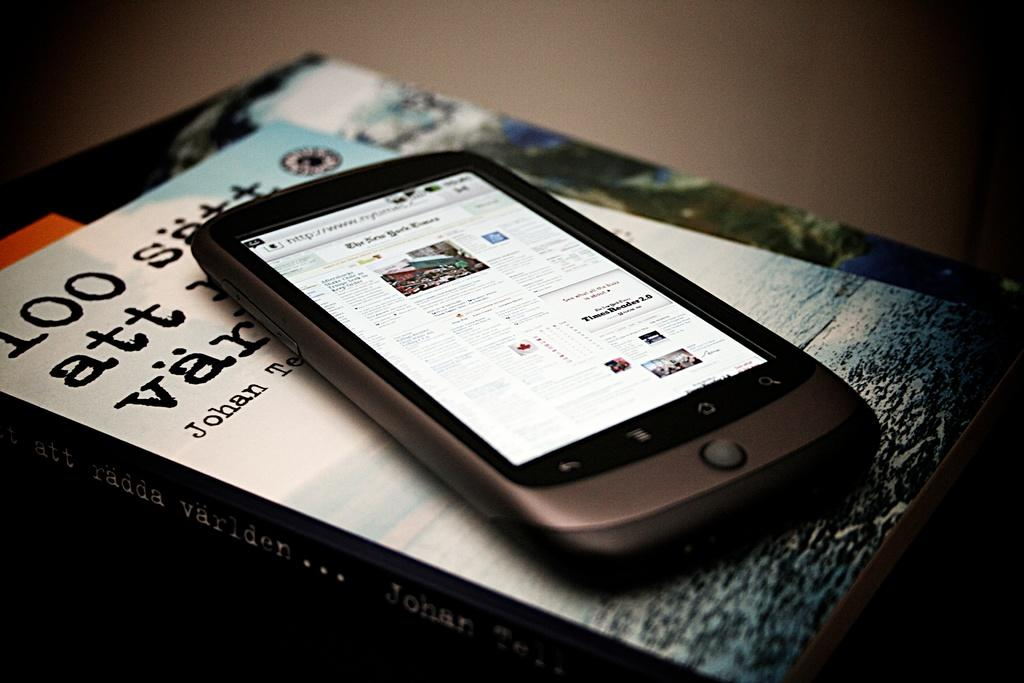<image>
Write a terse but informative summary of the picture. A book written by an author with the first name Johan has a cell phone on top of it. 